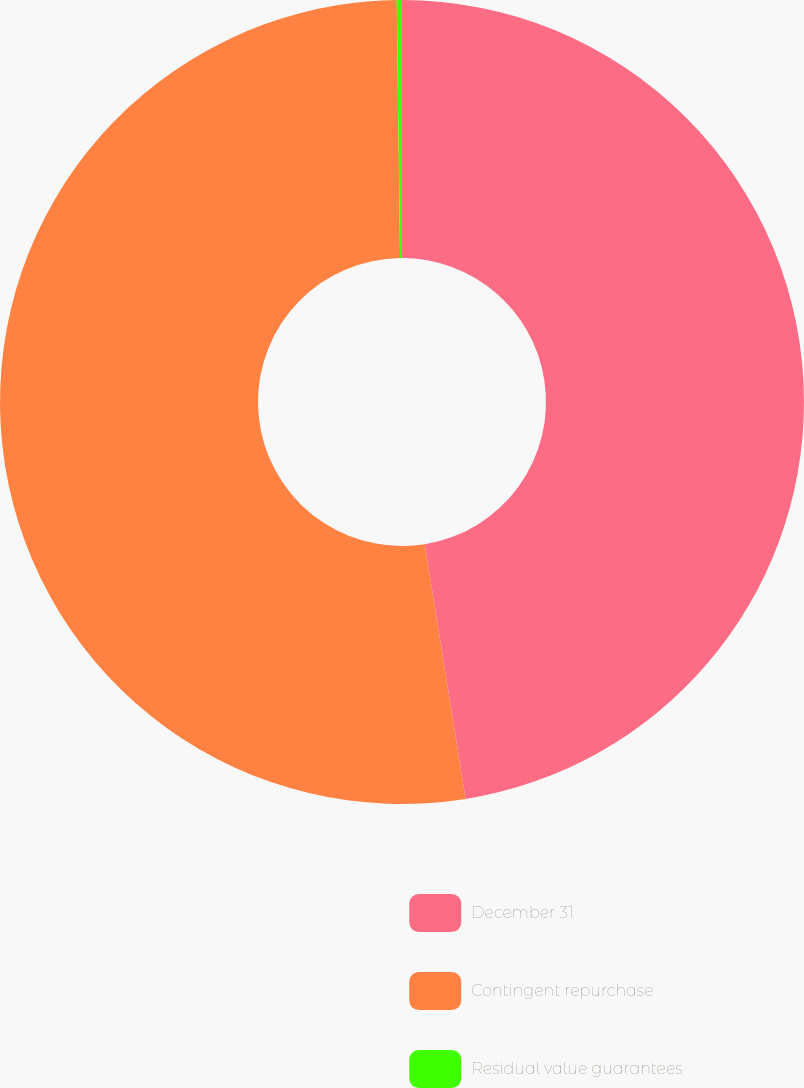Convert chart. <chart><loc_0><loc_0><loc_500><loc_500><pie_chart><fcel>December 31<fcel>Contingent repurchase<fcel>Residual value guarantees<nl><fcel>47.47%<fcel>52.32%<fcel>0.21%<nl></chart> 